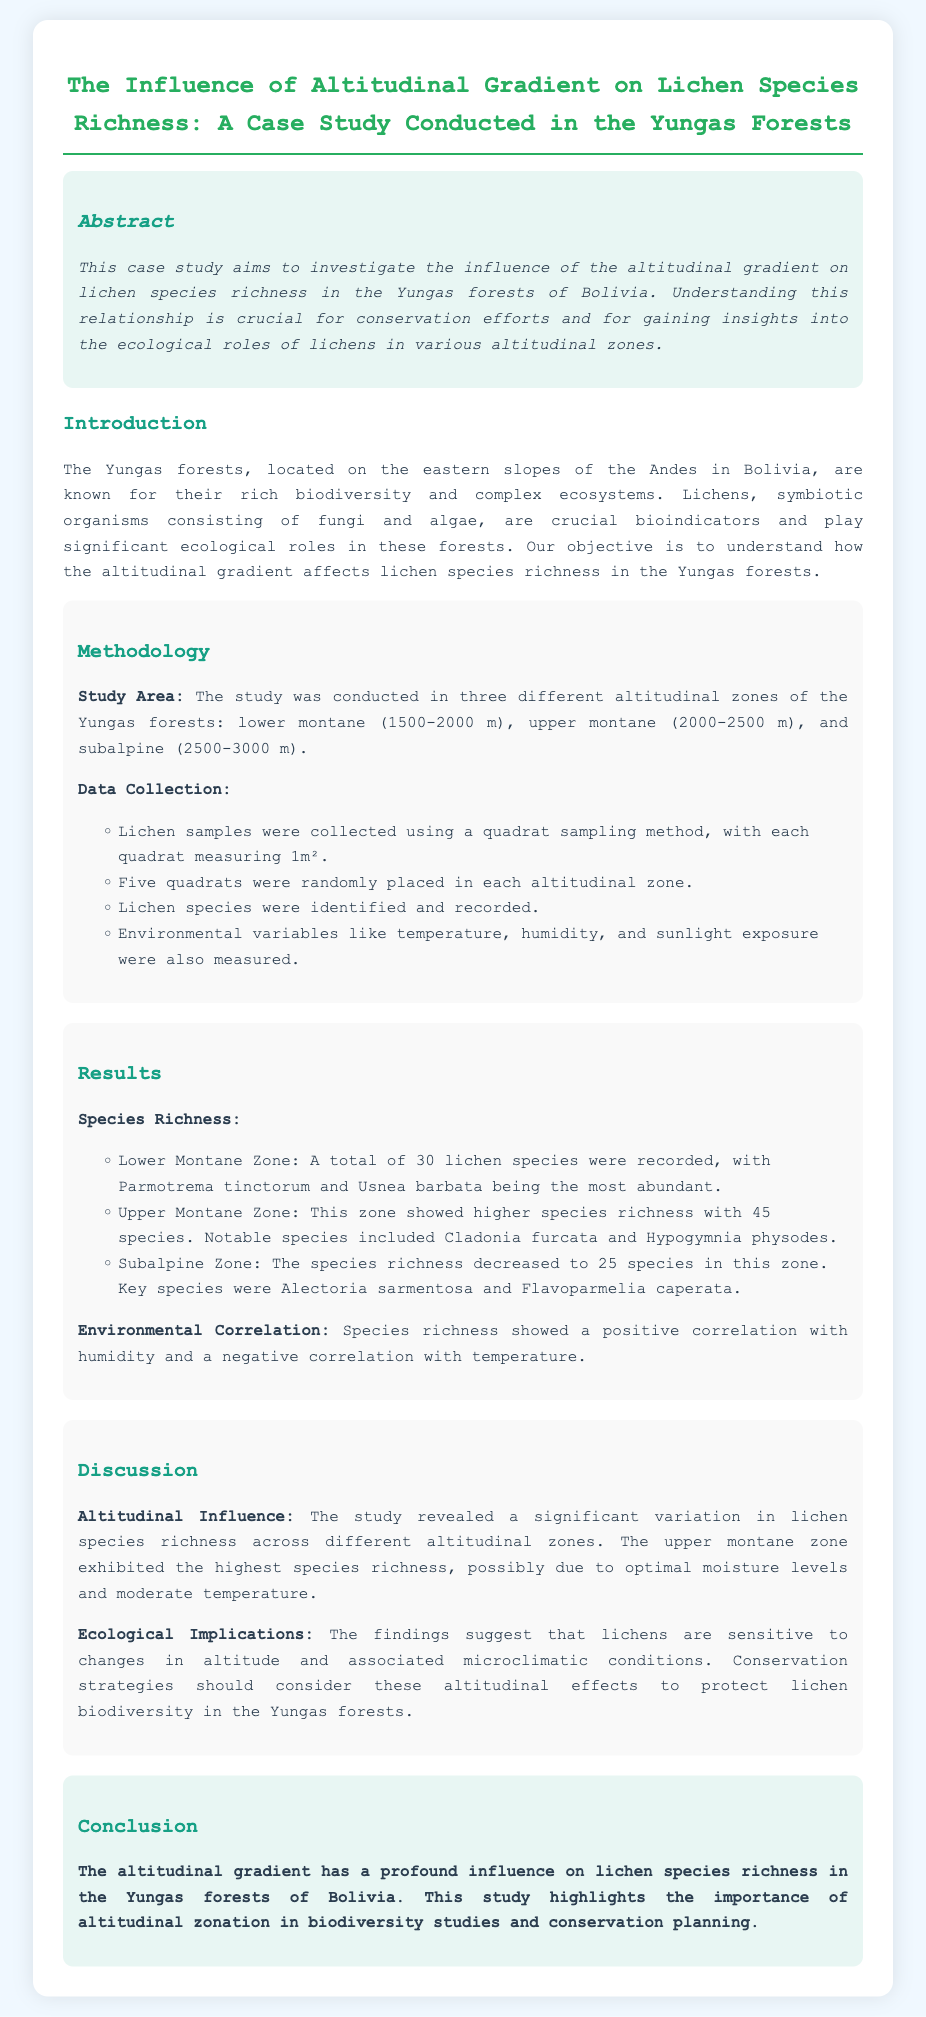What is the main focus of the case study? The focus of the case study is to investigate how the altitudinal gradient influences lichen species richness in the Yungas forests.
Answer: influence of the altitudinal gradient on lichen species richness What altitudinal zones were studied? The study examined three altitudinal zones: lower montane, upper montane, and subalpine.
Answer: lower montane, upper montane, subalpine How many lichen species were recorded in the Upper Montane Zone? The Upper Montane Zone recorded a total of 45 lichen species.
Answer: 45 species What environmental variable showed a positive correlation with species richness? The document states that humidity showed a positive correlation with species richness.
Answer: humidity Which species was the most abundant in the Lower Montane Zone? The most abundant species in the Lower Montane Zone was Parmotrema tinctorum.
Answer: Parmotrema tinctorum What trend was observed regarding lichen species richness with altitude? The study found that the species richness varied significantly with altitude, with the upper montane zone having the highest richness.
Answer: significant variation in lichen species richness What does the study suggest regarding conservation strategies? The study suggests that conservation strategies should consider altitudinal effects to protect lichen biodiversity.
Answer: consider altitudinal effects What is the ecological role of lichens in the Yungas forests? Lichens are described as crucial bioindicators with significant ecological roles in the Yungas forests.
Answer: crucial bioindicators How was data collected during the study? Data was collected through a quadrat sampling method in each altitudinal zone.
Answer: quadrat sampling method 